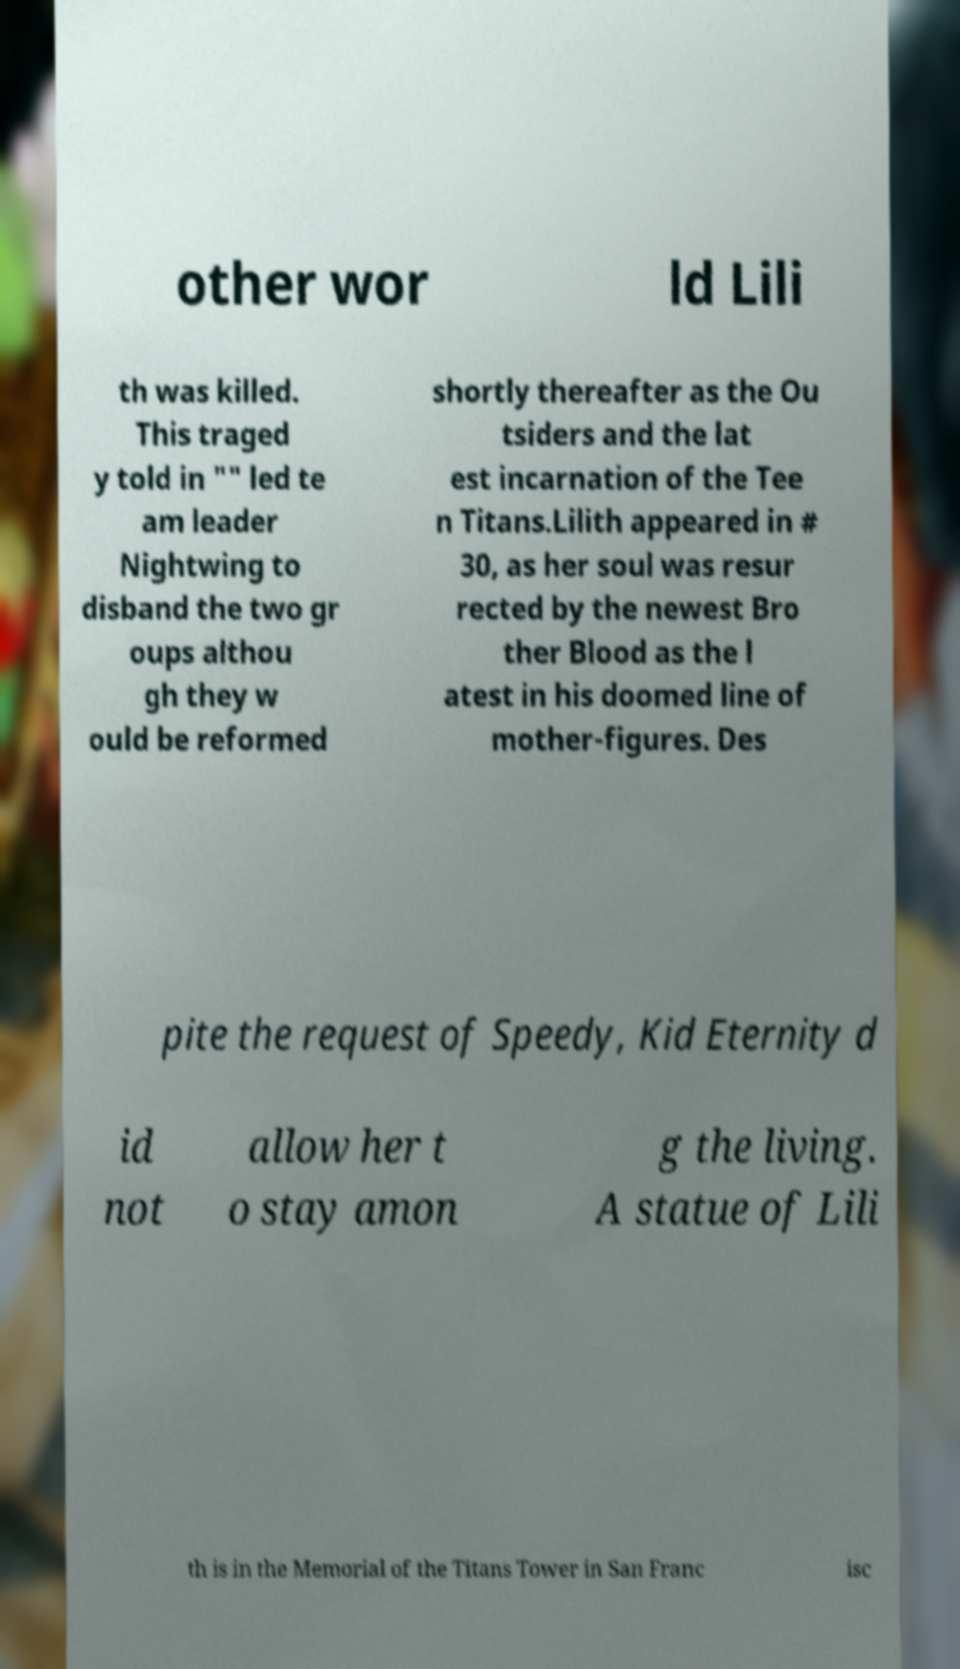Can you accurately transcribe the text from the provided image for me? other wor ld Lili th was killed. This traged y told in "" led te am leader Nightwing to disband the two gr oups althou gh they w ould be reformed shortly thereafter as the Ou tsiders and the lat est incarnation of the Tee n Titans.Lilith appeared in # 30, as her soul was resur rected by the newest Bro ther Blood as the l atest in his doomed line of mother-figures. Des pite the request of Speedy, Kid Eternity d id not allow her t o stay amon g the living. A statue of Lili th is in the Memorial of the Titans Tower in San Franc isc 